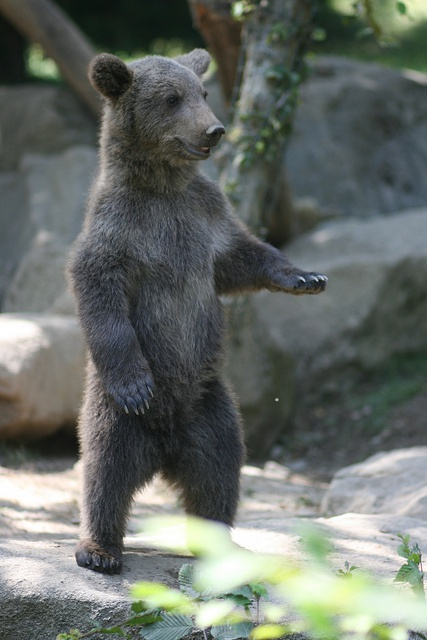Describe the objects in this image and their specific colors. I can see a bear in black, gray, and darkgray tones in this image. 